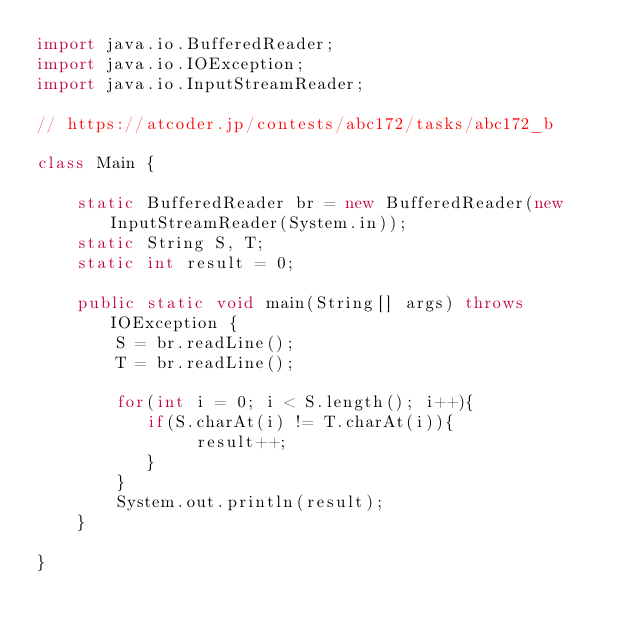Convert code to text. <code><loc_0><loc_0><loc_500><loc_500><_Java_>import java.io.BufferedReader;
import java.io.IOException;
import java.io.InputStreamReader;

// https://atcoder.jp/contests/abc172/tasks/abc172_b

class Main {

    static BufferedReader br = new BufferedReader(new InputStreamReader(System.in));
    static String S, T;
    static int result = 0;

    public static void main(String[] args) throws IOException {
        S = br.readLine();
        T = br.readLine();
        
        for(int i = 0; i < S.length(); i++){
           if(S.charAt(i) != T.charAt(i)){
                result++;
           }
        }
        System.out.println(result);
    }

}</code> 